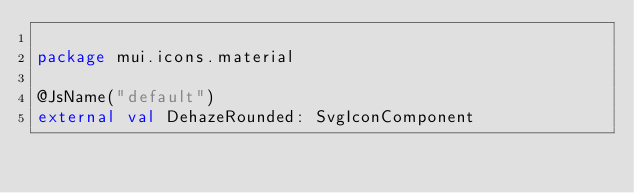Convert code to text. <code><loc_0><loc_0><loc_500><loc_500><_Kotlin_>
package mui.icons.material

@JsName("default")
external val DehazeRounded: SvgIconComponent
</code> 